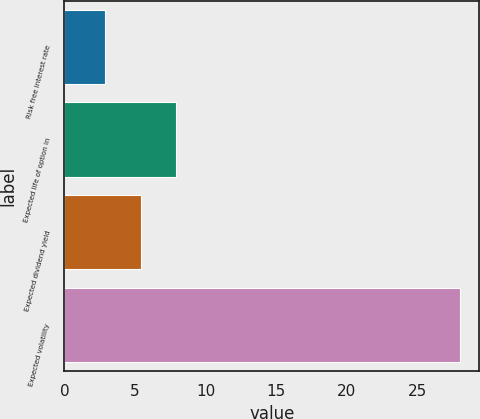Convert chart. <chart><loc_0><loc_0><loc_500><loc_500><bar_chart><fcel>Risk free interest rate<fcel>Expected life of option in<fcel>Expected dividend yield<fcel>Expected volatility<nl><fcel>2.9<fcel>7.92<fcel>5.41<fcel>28<nl></chart> 